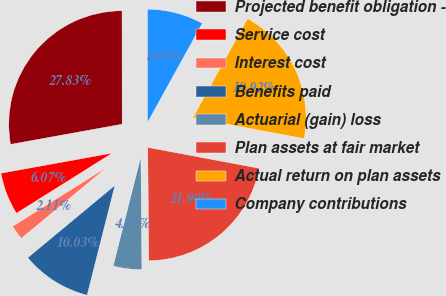Convert chart to OTSL. <chart><loc_0><loc_0><loc_500><loc_500><pie_chart><fcel>Projected benefit obligation -<fcel>Service cost<fcel>Interest cost<fcel>Benefits paid<fcel>Actuarial (gain) loss<fcel>Plan assets at fair market<fcel>Actual return on plan assets<fcel>Company contributions<nl><fcel>27.83%<fcel>6.07%<fcel>2.11%<fcel>10.03%<fcel>4.09%<fcel>21.9%<fcel>19.92%<fcel>8.05%<nl></chart> 